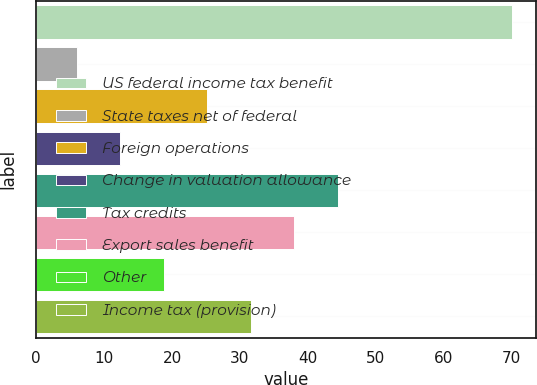Convert chart. <chart><loc_0><loc_0><loc_500><loc_500><bar_chart><fcel>US federal income tax benefit<fcel>State taxes net of federal<fcel>Foreign operations<fcel>Change in valuation allowance<fcel>Tax credits<fcel>Export sales benefit<fcel>Other<fcel>Income tax (provision)<nl><fcel>70<fcel>6<fcel>25.2<fcel>12.4<fcel>44.4<fcel>38<fcel>18.8<fcel>31.6<nl></chart> 